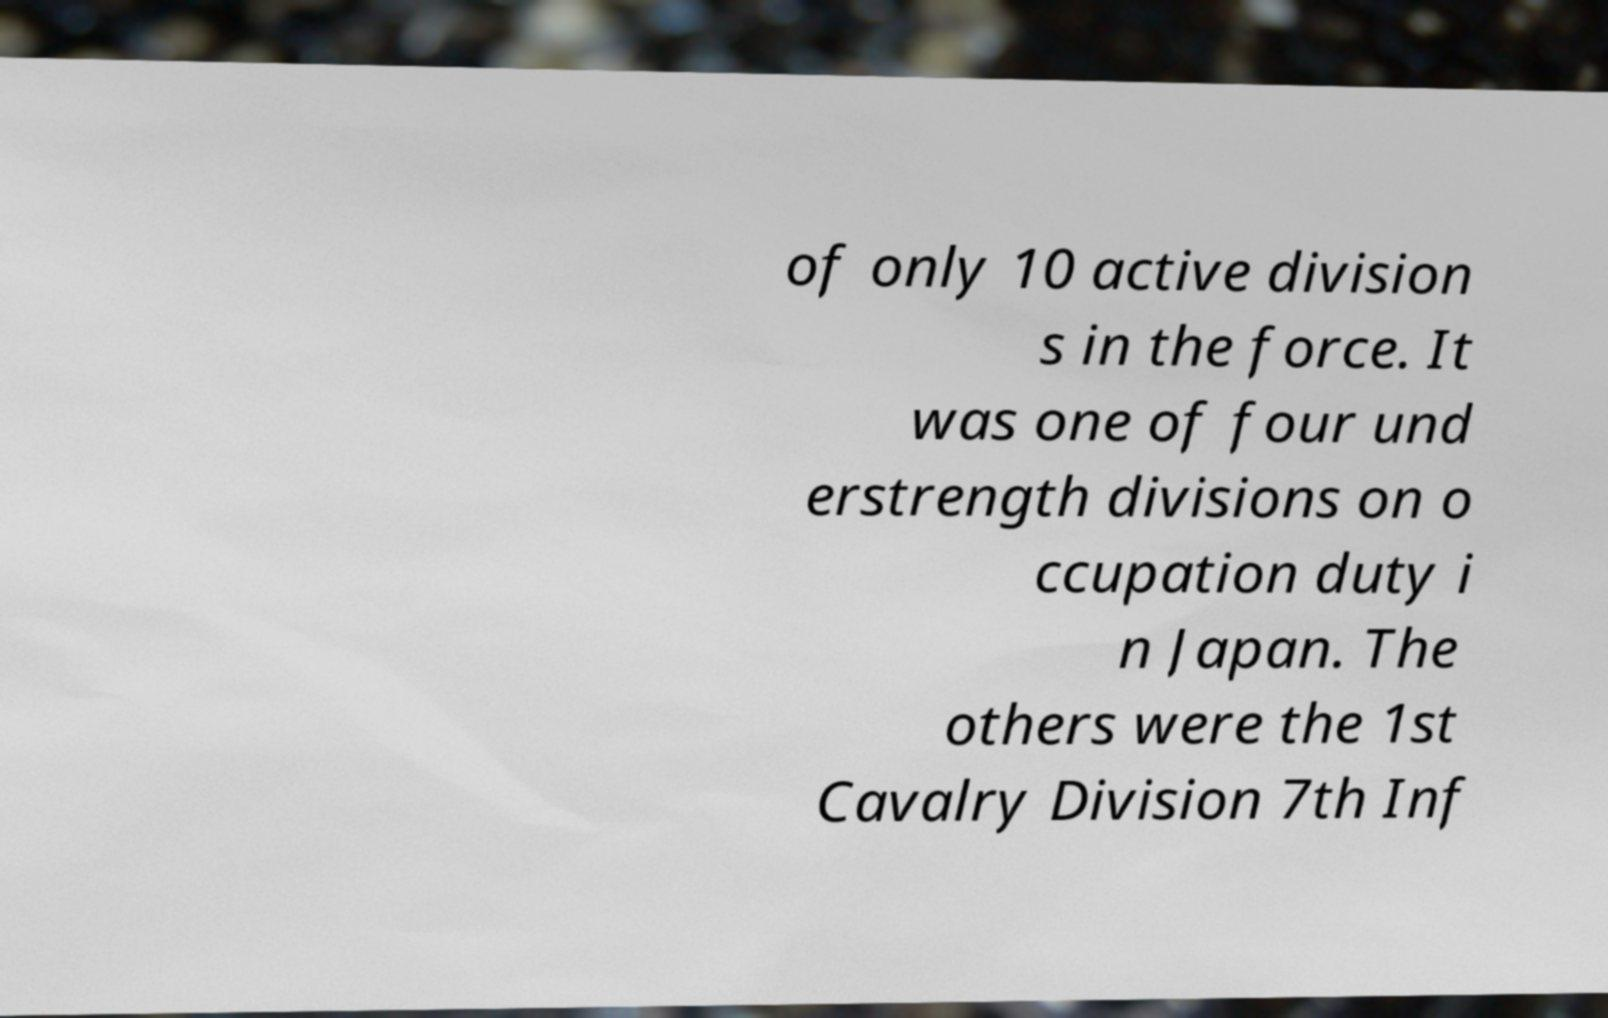For documentation purposes, I need the text within this image transcribed. Could you provide that? of only 10 active division s in the force. It was one of four und erstrength divisions on o ccupation duty i n Japan. The others were the 1st Cavalry Division 7th Inf 